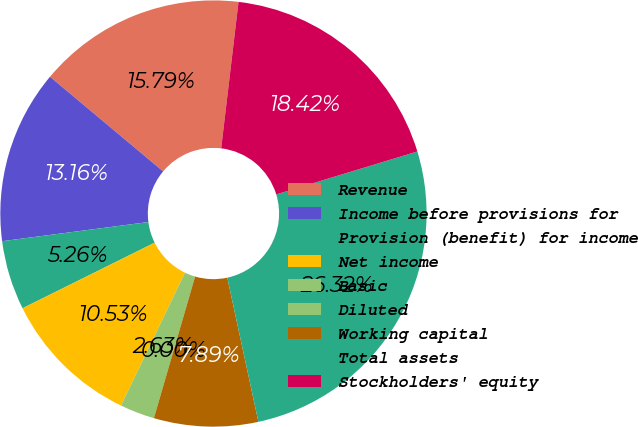Convert chart. <chart><loc_0><loc_0><loc_500><loc_500><pie_chart><fcel>Revenue<fcel>Income before provisions for<fcel>Provision (benefit) for income<fcel>Net income<fcel>Basic<fcel>Diluted<fcel>Working capital<fcel>Total assets<fcel>Stockholders' equity<nl><fcel>15.79%<fcel>13.16%<fcel>5.26%<fcel>10.53%<fcel>2.63%<fcel>0.0%<fcel>7.89%<fcel>26.32%<fcel>18.42%<nl></chart> 